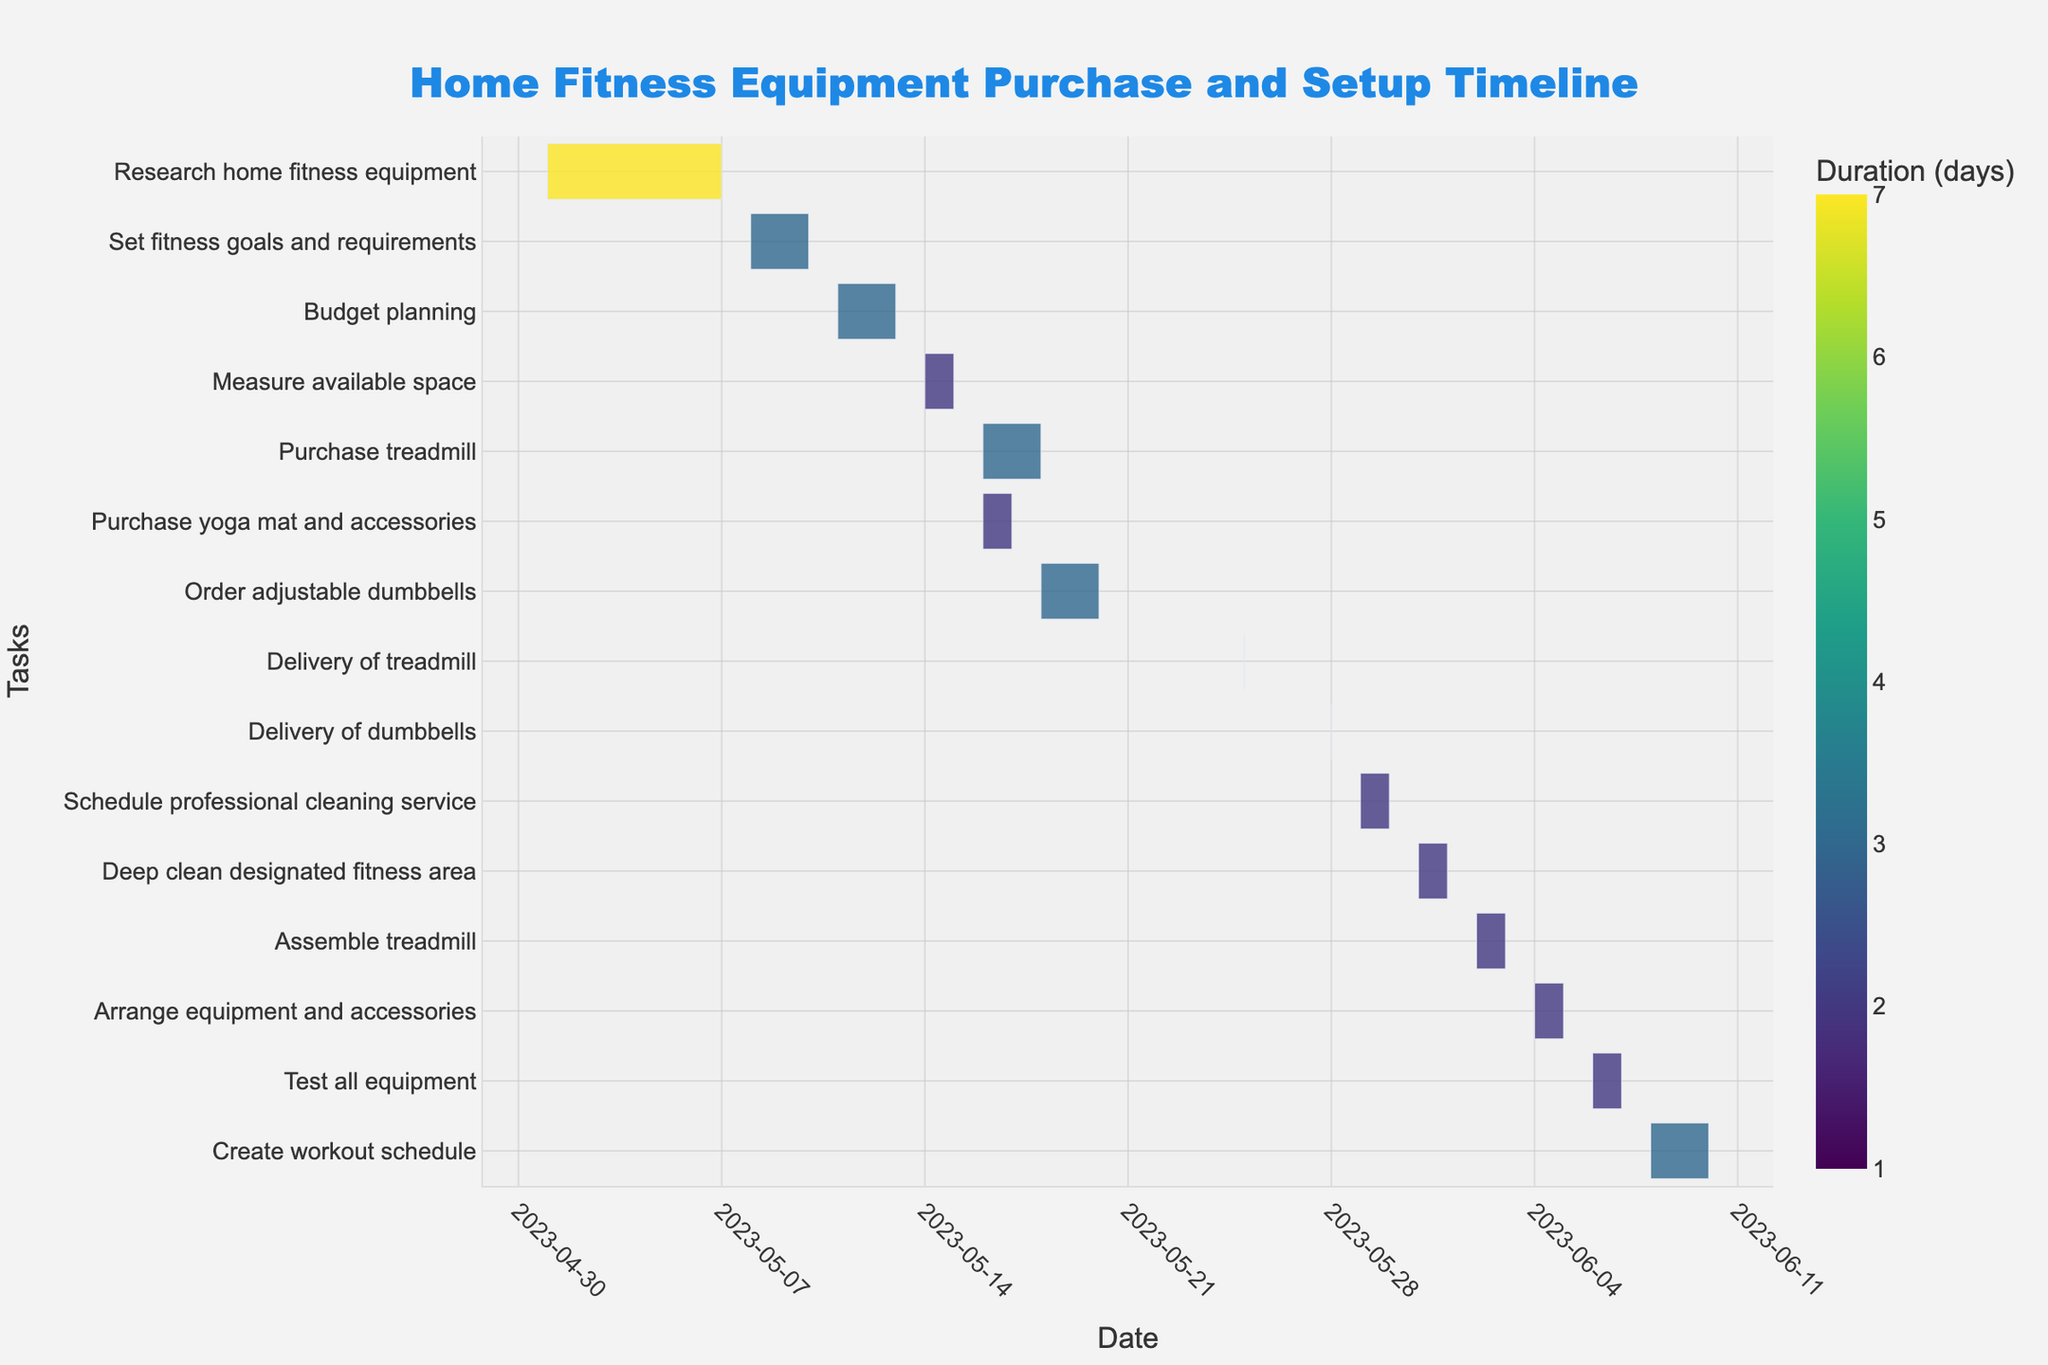What is the title of the Gantt chart? The title of the Gantt chart is prominently displayed at the top of the chart, centered and in large font size. It reads "Home Fitness Equipment Purchase and Setup Timeline".
Answer: Home Fitness Equipment Purchase and Setup Timeline What is the duration of the "Budget planning" task? To find the duration, locate the "Budget planning" task on the chart. The duration is the difference between the start and end dates plus one day. The start date is 2023-05-11 and the end date is 2023-05-13; thus, the duration is (13 - 11) + 1 = 3 days.
Answer: 3 days Which task has the longest duration? To determine the longest duration, scan the chart for the task bars with the longest horizontal length. Compare the durations indicated. From the chart, "Create workout schedule" has the longest duration, lasting from 2023-06-08 to 2023-06-10, which is 3 days.
Answer: Create workout schedule Which tasks are scheduled to start on 2023-05-16? Look at the vertical axis and find the start point of 2023-05-16. Follow the horizontal bars of tasks starting on this date. The tasks "Purchase treadmill" and "Purchase yoga mat and accessories" both start on 2023-05-16.
Answer: Purchase treadmill, Purchase yoga mat and accessories What is the combined duration of "Research home fitness equipment" and "Set fitness goals and requirements"? To find the combined duration, sum the durations of both tasks. "Research home fitness equipment" runs from 2023-05-01 to 2023-05-07 which is 7 days, and "Set fitness goals and requirements" runs from 2023-05-08 to 2023-05-10 which is 3 days. Therefore, the combined duration is 7 + 3 = 10 days.
Answer: 10 days Which tasks are scheduled for delivery, and what are their dates? Identify the tasks that mention delivery by reading the task names. The tasks are "Delivery of treadmill" on 2023-05-25 and "Delivery of dumbbells" on 2023-05-28.
Answer: Delivery of treadmill (2023-05-25), Delivery of dumbbells (2023-05-28) Which task involves 'deep cleaning', and when does it occur? Look at the chart for any task related to 'deep cleaning'. The task "Deep clean designated fitness area" is scheduled from 2023-05-31 to 2023-06-01.
Answer: Deep clean designated fitness area (2023-05-31 to 2023-06-01) What tasks occur immediately after the delivery of dumbbells? Find the "Delivery of dumbbells" task on 2023-05-28, then look at the tasks that follow immediately in the timeline. "Schedule professional cleaning service" starts immediately after on 2023-05-29.
Answer: Schedule professional cleaning service How is the color of a task determined in the chart? The color of a task in a Gantt chart is determined by its duration. Each color represents a different duration with a continuous color scale used to visually represent these differences.
Answer: By duration 